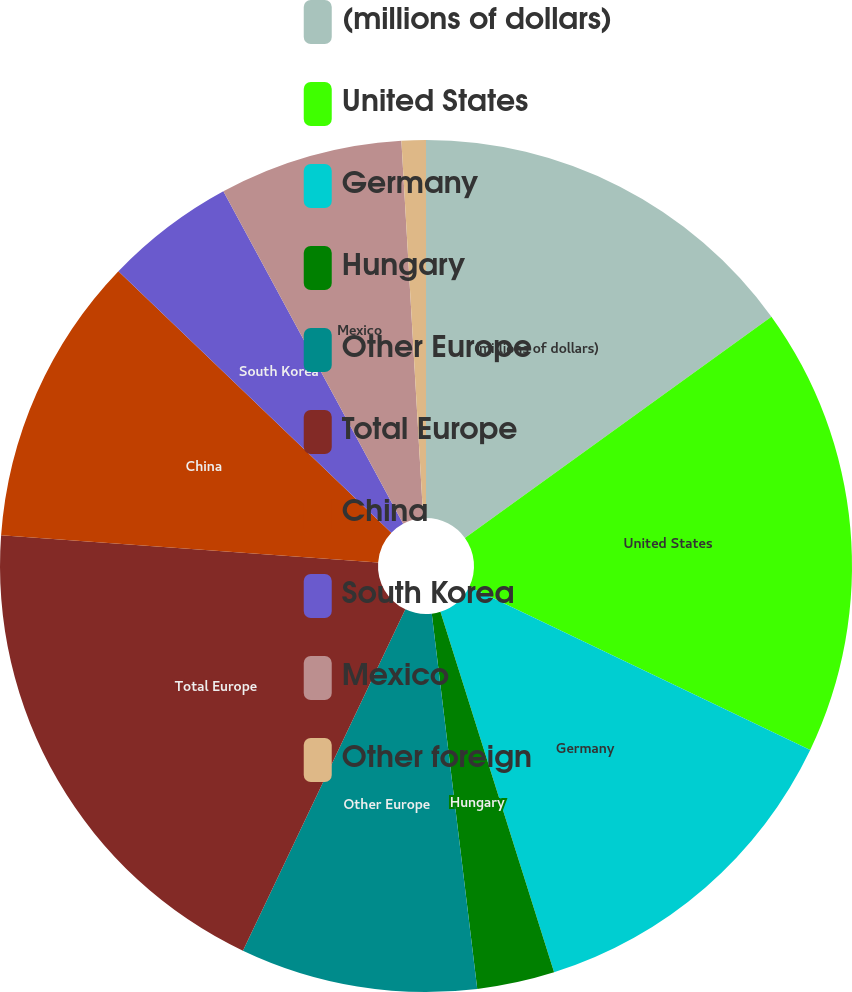Convert chart. <chart><loc_0><loc_0><loc_500><loc_500><pie_chart><fcel>(millions of dollars)<fcel>United States<fcel>Germany<fcel>Hungary<fcel>Other Europe<fcel>Total Europe<fcel>China<fcel>South Korea<fcel>Mexico<fcel>Other foreign<nl><fcel>15.05%<fcel>17.06%<fcel>13.03%<fcel>2.94%<fcel>8.99%<fcel>19.08%<fcel>11.01%<fcel>4.95%<fcel>6.97%<fcel>0.92%<nl></chart> 